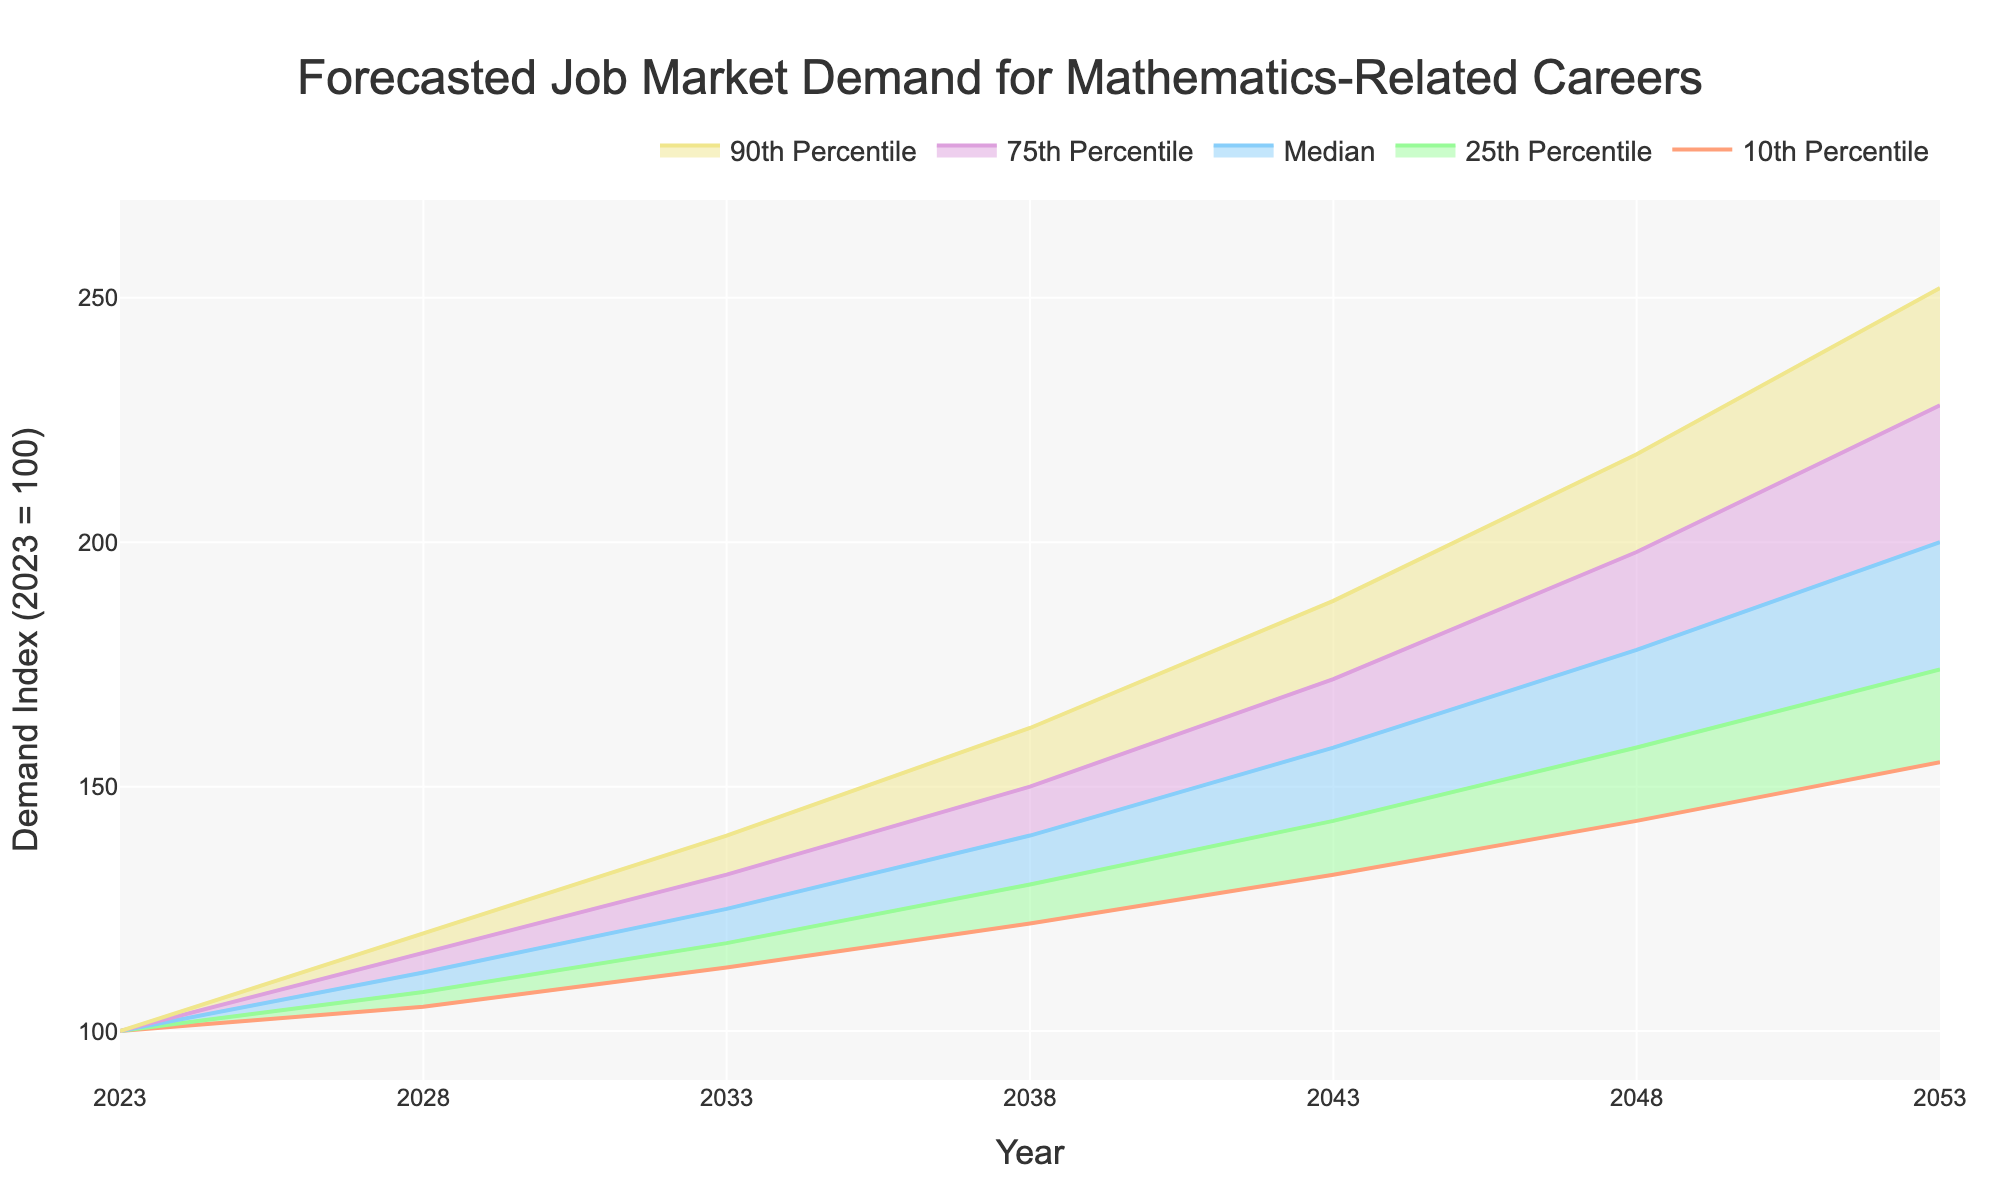What is the title of the figure? The title is usually located at the top center of the chart. In this case, it states the overall topic of the figure.
Answer: Forecasted Job Market Demand for Mathematics-Related Careers How often are the data points recorded in the figure? Check the x-axis to see the time intervals between the data points.
Answer: Every 5 years What is the y-axis title of the figure? The y-axis title is located along the vertical axis of the chart.
Answer: Demand Index (2023 = 100) What is the median forecasted demand index for the year 2043? Look for the median line (the one associated with "Median" in the legend). Find the value for the year 2043.
Answer: 158 In what year does the median forecasted demand index first surpass 150? Look for the year where the median line (associated with "Median") first passes the 150 value.
Answer: 2043 What is the demand index at the 75th percentile in 2038? Identify the value of the 75th percentile line (associated with "75th Percentile") for the year 2038.
Answer: 150 